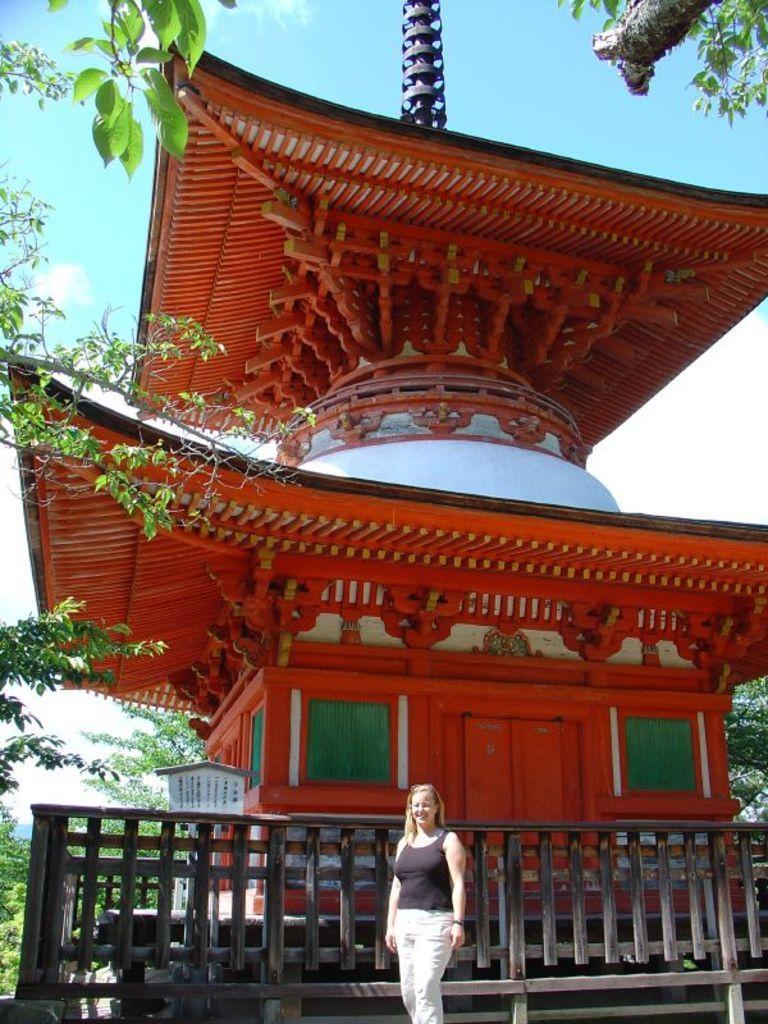Can you describe this image briefly? In the foreground of this image, there is a woman standing in front of a Japanese architecture. On the either side of the image, there are trees. In the background, there are few trees, sky and the cloud. 